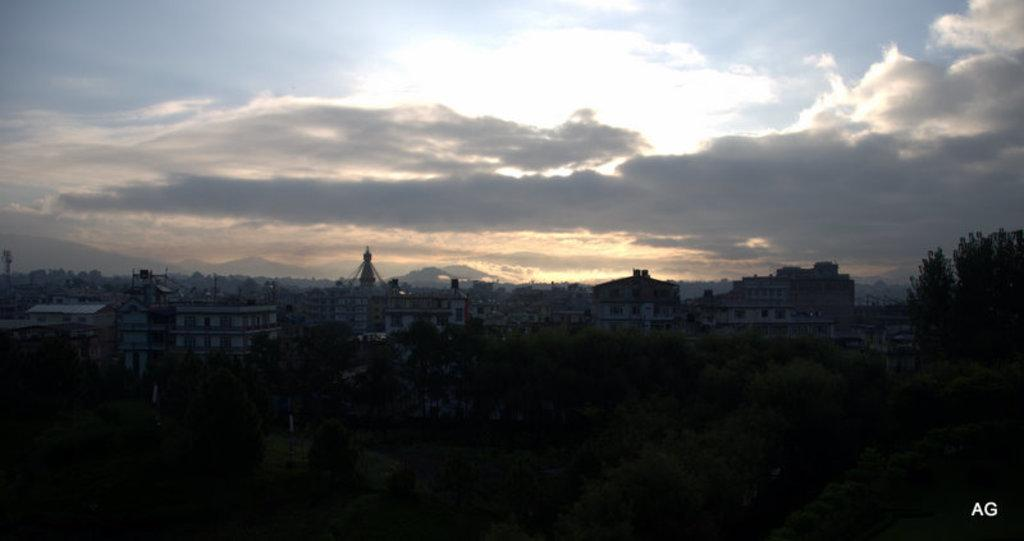What can be seen in the sky in the image? The sky is visible in the image. What type of structure is present in the image? There is a building in the image. What other natural elements can be seen in the image? There are trees in the image. How would you describe the lighting in the bottom part of the image? The bottom part of the image is very dark. What type of pancake is being served on the tree in the image? There is no pancake present in the image, and the tree is not serving any food. 